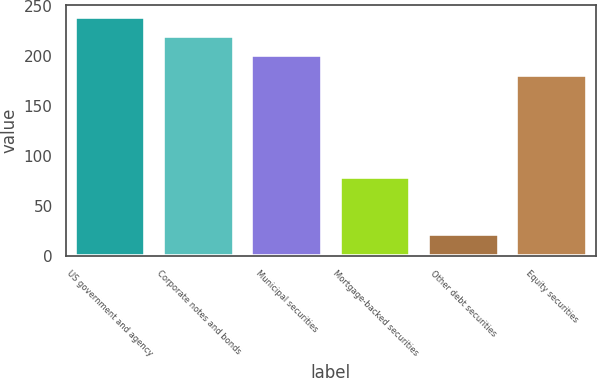<chart> <loc_0><loc_0><loc_500><loc_500><bar_chart><fcel>US government and agency<fcel>Corporate notes and bonds<fcel>Municipal securities<fcel>Mortgage-backed securities<fcel>Other debt securities<fcel>Equity securities<nl><fcel>239.77<fcel>220.38<fcel>200.99<fcel>79.4<fcel>21.7<fcel>181.6<nl></chart> 